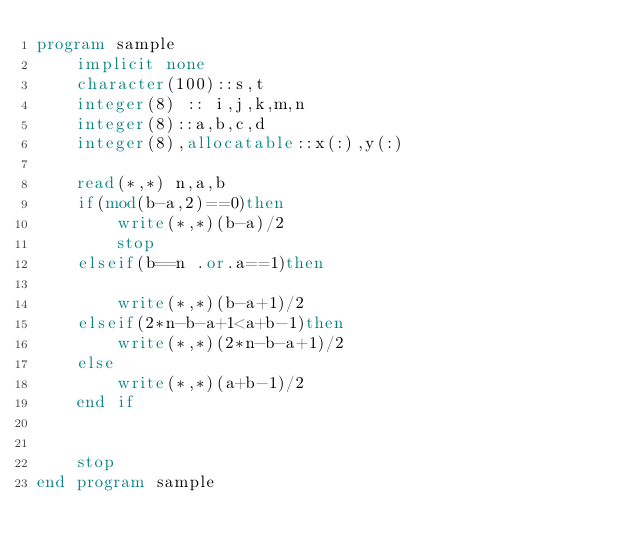Convert code to text. <code><loc_0><loc_0><loc_500><loc_500><_FORTRAN_>program sample
    implicit none
    character(100)::s,t
    integer(8) :: i,j,k,m,n
    integer(8)::a,b,c,d
    integer(8),allocatable::x(:),y(:)
  
    read(*,*) n,a,b
    if(mod(b-a,2)==0)then
        write(*,*)(b-a)/2
        stop
    elseif(b==n .or.a==1)then

        write(*,*)(b-a+1)/2
    elseif(2*n-b-a+1<a+b-1)then
        write(*,*)(2*n-b-a+1)/2
    else
        write(*,*)(a+b-1)/2
    end if


    stop
end program sample
  

</code> 